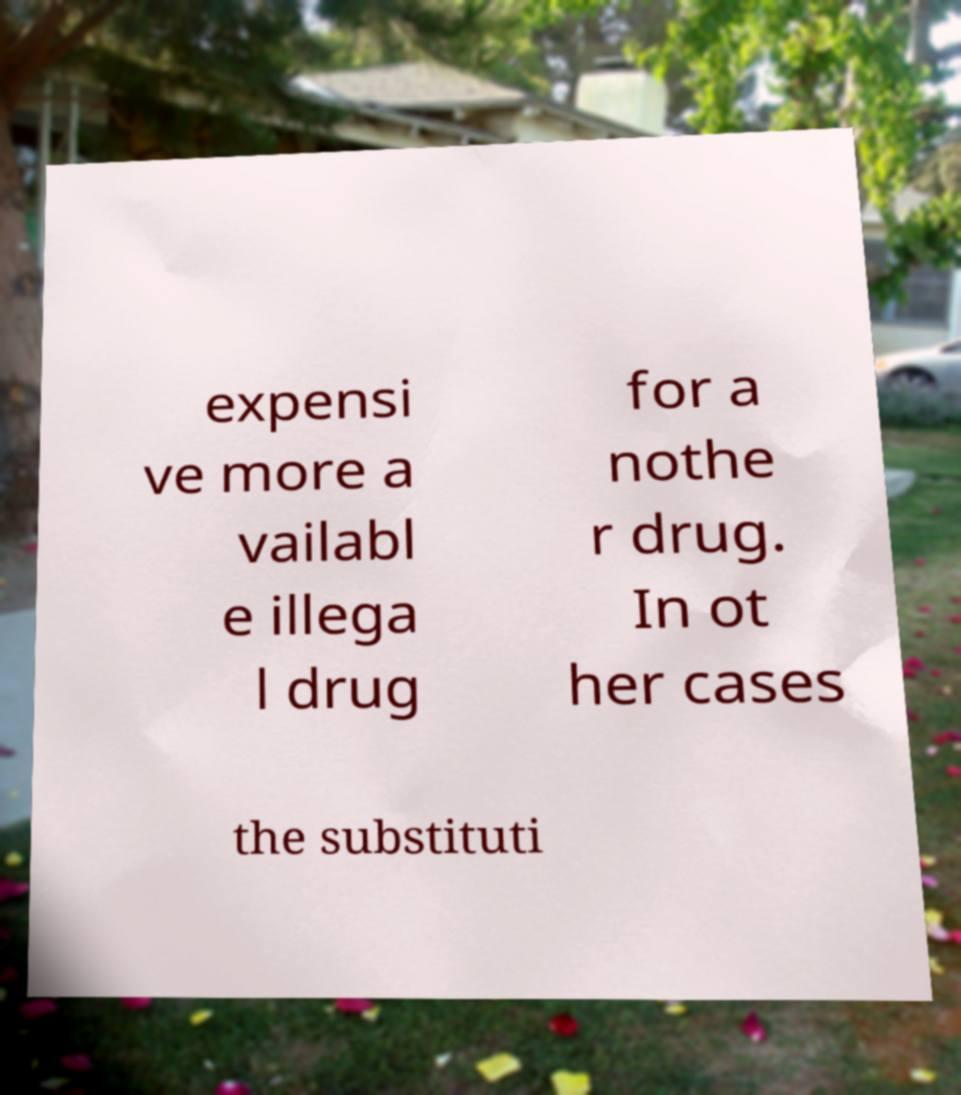I need the written content from this picture converted into text. Can you do that? expensi ve more a vailabl e illega l drug for a nothe r drug. In ot her cases the substituti 